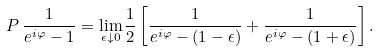Convert formula to latex. <formula><loc_0><loc_0><loc_500><loc_500>P \, \frac { 1 } { e ^ { i \varphi } - 1 } = \lim _ { \epsilon \downarrow 0 } \frac { 1 } { 2 } \left [ \frac { 1 } { e ^ { i \varphi } - ( 1 - \epsilon ) } + \frac { 1 } { e ^ { i \varphi } - ( 1 + \epsilon ) } \right ] .</formula> 